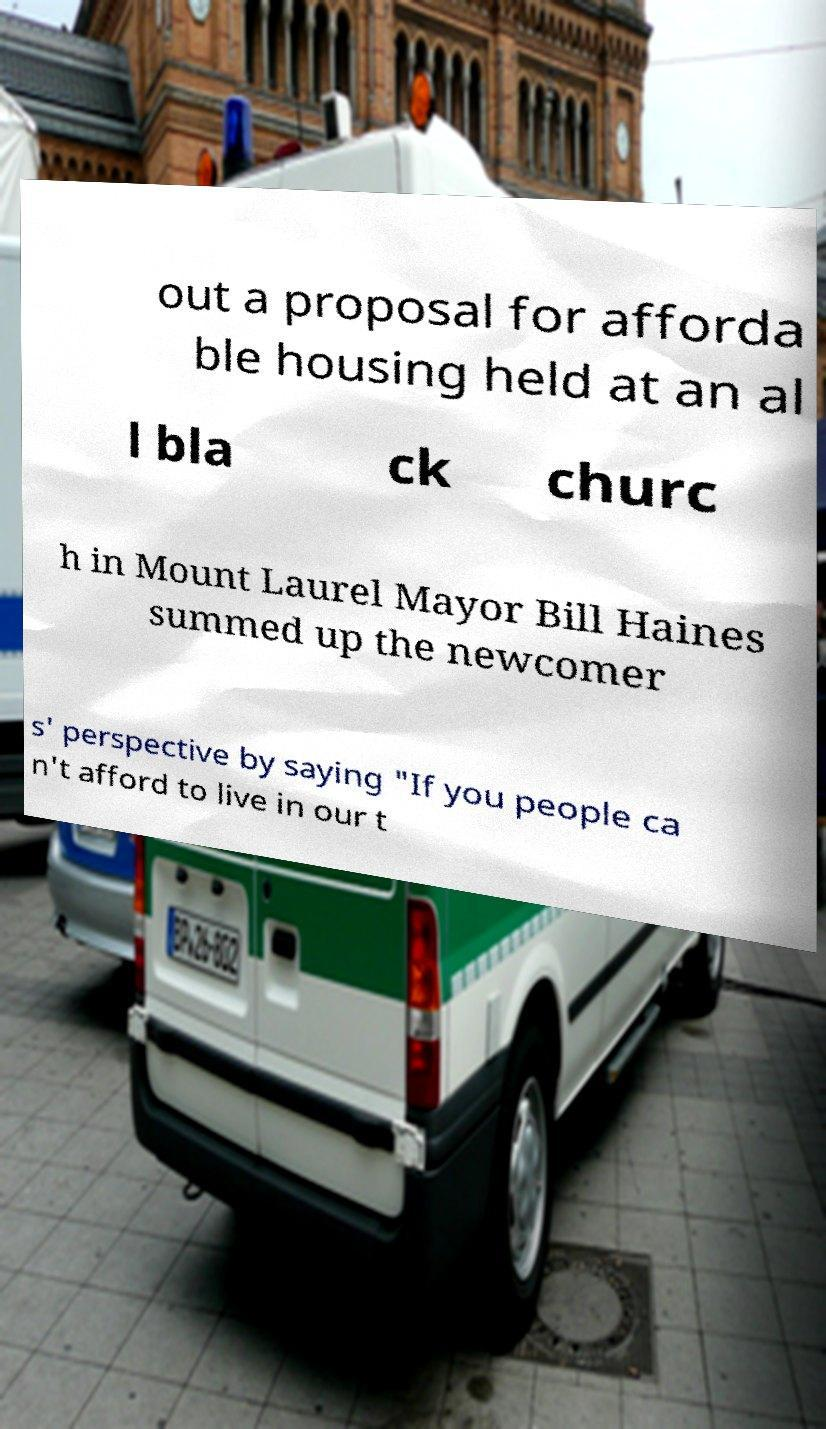Can you accurately transcribe the text from the provided image for me? out a proposal for afforda ble housing held at an al l bla ck churc h in Mount Laurel Mayor Bill Haines summed up the newcomer s' perspective by saying "If you people ca n't afford to live in our t 